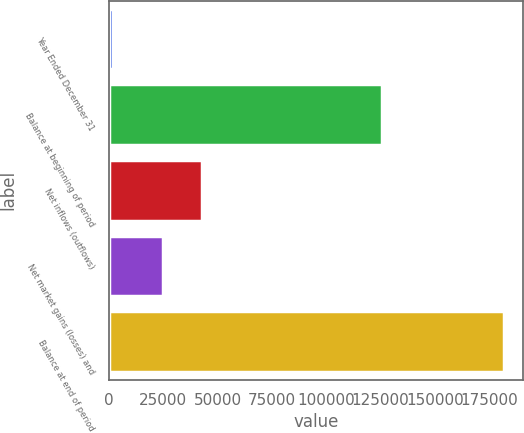Convert chart. <chart><loc_0><loc_0><loc_500><loc_500><bar_chart><fcel>Year Ended December 31<fcel>Balance at beginning of period<fcel>Net inflows (outflows)<fcel>Net market gains (losses) and<fcel>Balance at end of period<nl><fcel>2017<fcel>125813<fcel>42983.1<fcel>25024<fcel>181608<nl></chart> 